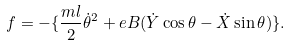Convert formula to latex. <formula><loc_0><loc_0><loc_500><loc_500>f = - \{ \frac { m l } { 2 } \dot { \theta } ^ { 2 } + e B ( \dot { Y } \cos \theta - \dot { X } \sin \theta ) \} .</formula> 